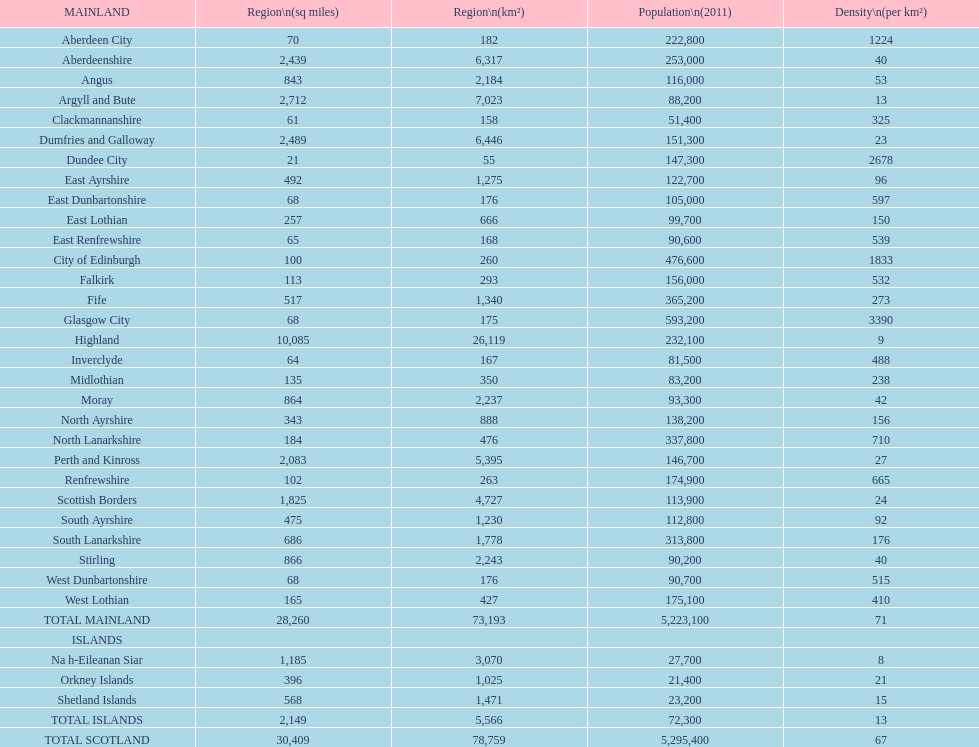Which mainland has the least population? Clackmannanshire. 